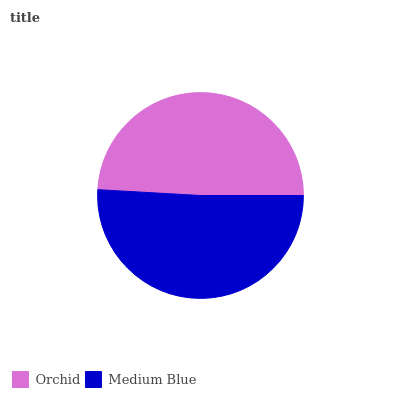Is Orchid the minimum?
Answer yes or no. Yes. Is Medium Blue the maximum?
Answer yes or no. Yes. Is Medium Blue the minimum?
Answer yes or no. No. Is Medium Blue greater than Orchid?
Answer yes or no. Yes. Is Orchid less than Medium Blue?
Answer yes or no. Yes. Is Orchid greater than Medium Blue?
Answer yes or no. No. Is Medium Blue less than Orchid?
Answer yes or no. No. Is Medium Blue the high median?
Answer yes or no. Yes. Is Orchid the low median?
Answer yes or no. Yes. Is Orchid the high median?
Answer yes or no. No. Is Medium Blue the low median?
Answer yes or no. No. 